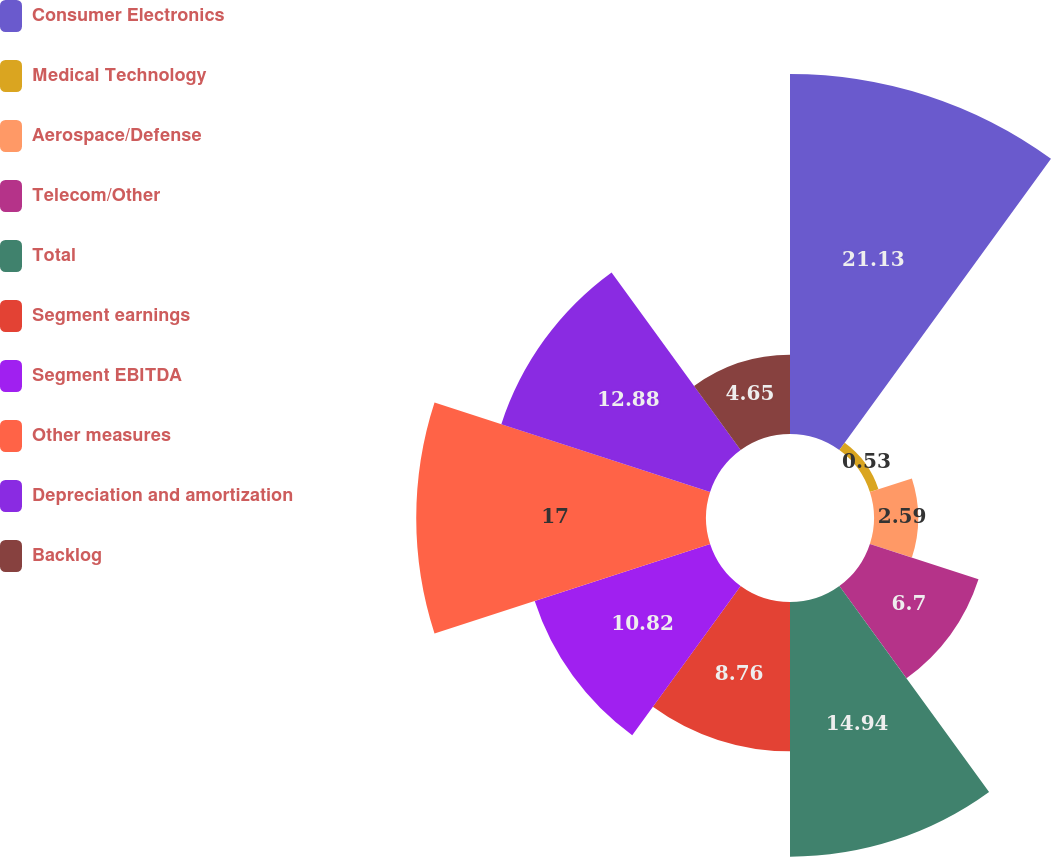Convert chart to OTSL. <chart><loc_0><loc_0><loc_500><loc_500><pie_chart><fcel>Consumer Electronics<fcel>Medical Technology<fcel>Aerospace/Defense<fcel>Telecom/Other<fcel>Total<fcel>Segment earnings<fcel>Segment EBITDA<fcel>Other measures<fcel>Depreciation and amortization<fcel>Backlog<nl><fcel>21.12%<fcel>0.53%<fcel>2.59%<fcel>6.7%<fcel>14.94%<fcel>8.76%<fcel>10.82%<fcel>17.0%<fcel>12.88%<fcel>4.65%<nl></chart> 